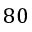Convert formula to latex. <formula><loc_0><loc_0><loc_500><loc_500>8 0</formula> 